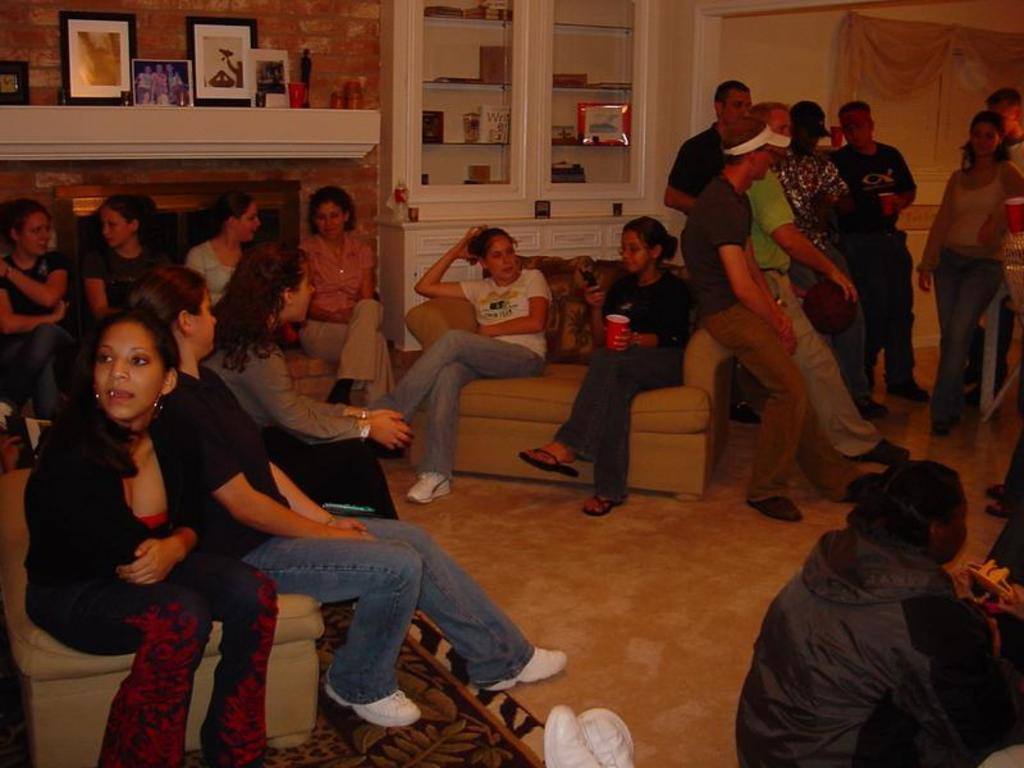What are the people in the image doing? There are people sitting and standing in the image. What can be seen behind the people? There are photo frames visible behind the people, and there is a wall behind them. What else can be seen behind the people? There are objects in cupboards visible behind the people. What is the star rating of the street in the image? There is no street or star rating present in the image. 